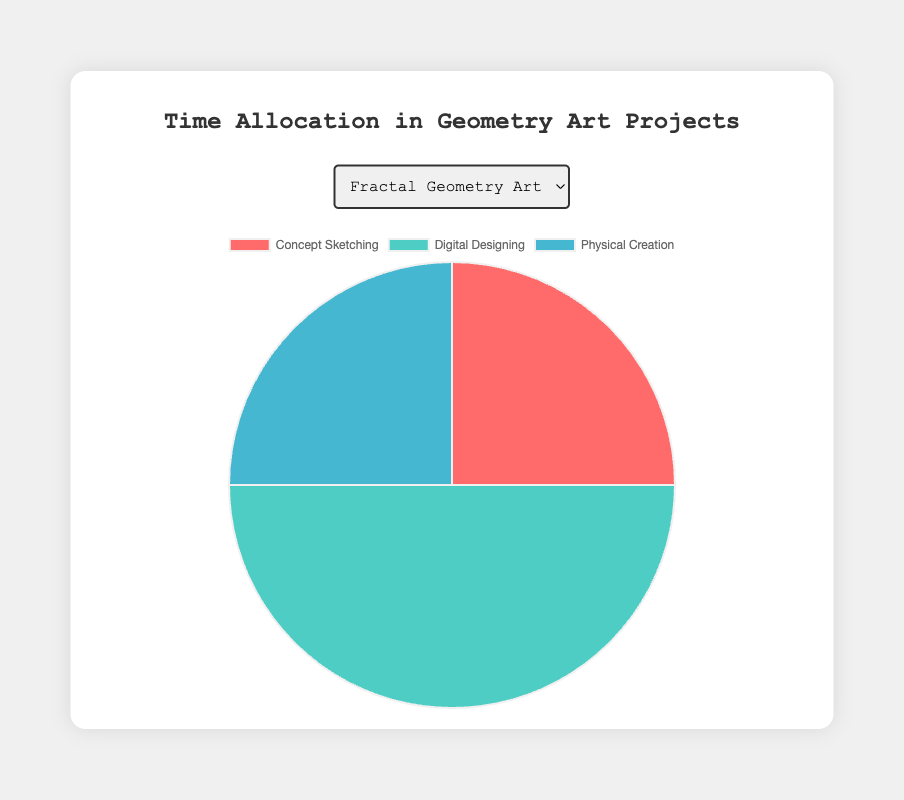What percentage of time is allocated to concept sketching in the Fractal Geometry Art project? The pie chart for the Fractal Geometry Art project shows three segments for the three activities. By examining the segment for concept sketching, we see it occupies 25% of the total time.
Answer: 25% Which project allocates the most time to digital designing? By comparing the segments representing digital designing across all three pie charts, we observe that the Parametric Sculpture project allocates the most time with 55%.
Answer: Parametric Sculpture What is the total time allocated to physical creation in the Tessellation Mural and Parametric Sculpture projects combined? For Tessellation Mural, the time allocated to physical creation is 30%. For Parametric Sculpture, it is also 30%. Therefore, the combined time is 30% + 30% = 60%.
Answer: 60% Considering concept sketching and physical creation activities together, which project allocates the least time to these combined activities? Summing the time allocations for concept sketching and physical creation in each project: Fractal Geometry Art: 25% + 25% = 50%, Tessellation Mural: 30% + 30% = 60%, Parametric Sculpture: 15% + 30% = 45%. Parametric Sculpture allocates the least combined time.
Answer: Parametric Sculpture What is the difference in time allocation for digital designing between Fractal Geometry Art and Tessellation Mural projects? The time allocated to digital designing in the Fractal Geometry Art project is 50%. In the Tessellation Mural project, it is 40%. The difference is 50% - 40% = 10%.
Answer: 10% Which activity is allocated the least time in the Parametric Sculpture project? Observing the pie chart for the Parametric Sculpture project, the smallest segment represents concept sketching with 15%.
Answer: Concept Sketching What percentage of the total project time for the Fractal Geometry Art project is allocated to activities other than digital designing? Digital designing for the Fractal Geometry Art project is 50%, so the remaining 50% (100% - 50%) is allocated to other activities.
Answer: 50% Comparing the pie charts, which project has the most balanced time allocation for its activities? Evaluating the proportions for each project, the Fractal Geometry Art (25%, 50%, 25%) and Tessellation Mural (30%, 40%, 30%) are fairly balanced, but Tessellation Mural has the most even distribution, as the difference between activities is smaller.
Answer: Tessellation Mural 